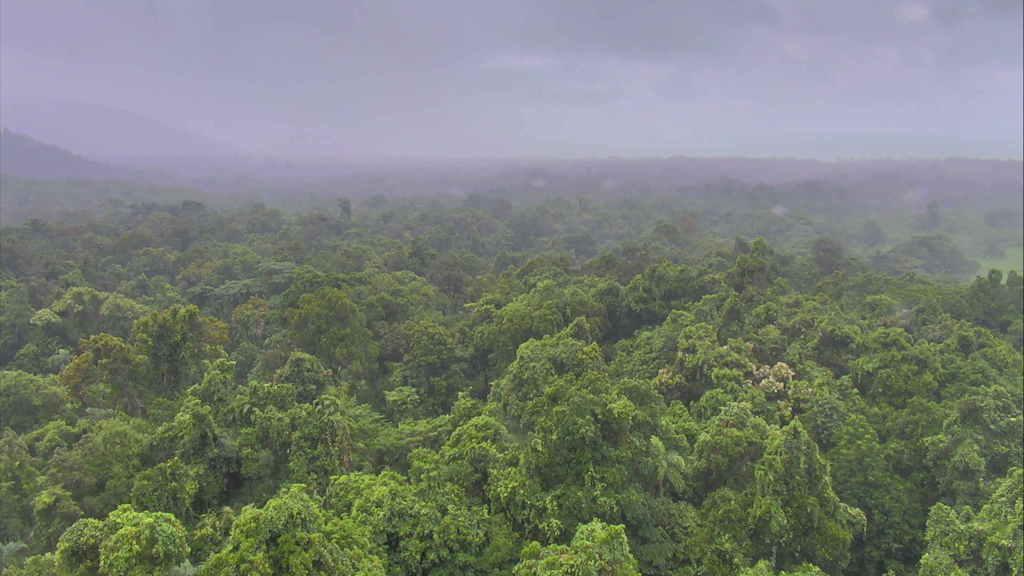In one or two sentences, can you explain what this image depicts? In the picture we can see an Aerial view of the forest with full of trees and in the background, we can see the hills and trees on and behind we can see a sky with clouds. 